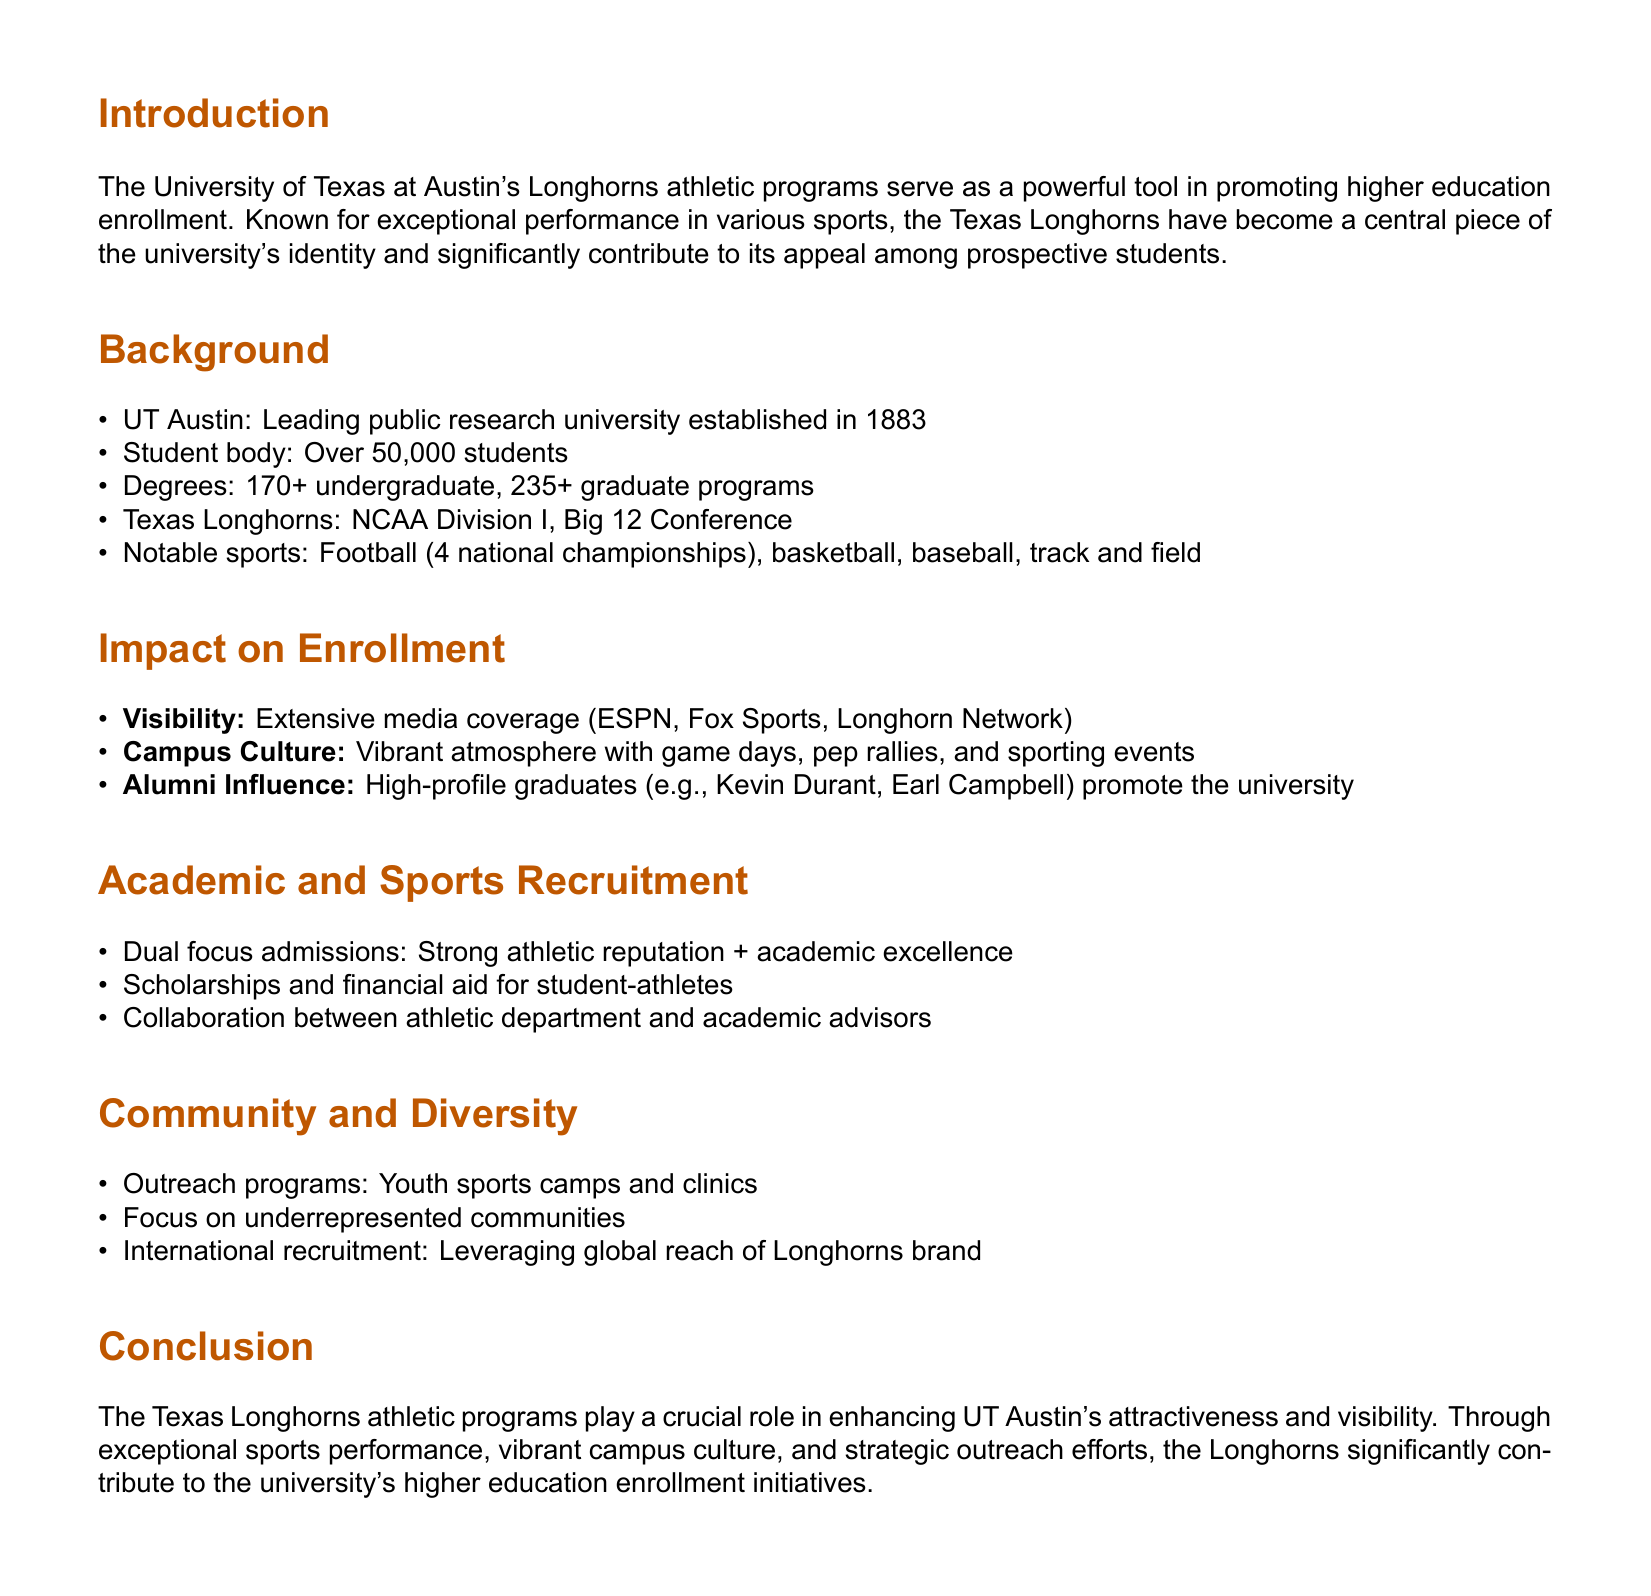What is the student body size of UT Austin? The document states that the student body consists of over 50,000 students.
Answer: Over 50,000 students How many national championships has the Texas Longhorns football team won? The document mentions that the football team has won 4 national championships.
Answer: 4 What is the focus of outreach programs mentioned in the document? The document indicates that outreach programs focus on underrepresented communities.
Answer: Underrepresented communities Which media outlets provide extensive coverage of the Longhorns? The document lists ESPN, Fox Sports, and Longhorn Network as the media outlets providing coverage.
Answer: ESPN, Fox Sports, Longhorn Network What is the dual focus in admissions for student-athletes? The document states that the dual focus in admissions is on strong athletic reputation and academic excellence.
Answer: Strong athletic reputation + academic excellence Who are two notable alumni mentioned that promote the university? The document cites Kevin Durant and Earl Campbell as high-profile graduates.
Answer: Kevin Durant, Earl Campbell What color represents the Texas Longhorns brand in this document? The document uses the RGB representation of burnt orange for the Texas Longhorns brand.
Answer: Burnt Orange What type of scholarships are provided for student-athletes? The document notes that scholarships and financial aid are available for student-athletes.
Answer: Scholarships and financial aid What year was UT Austin established? The document states that UT Austin was established in 1883.
Answer: 1883 What is the concluding statement about the Texas Longhorns athletic programs? The document concludes that the athletic programs significantly contribute to higher education enrollment initiatives.
Answer: Significantly contribute to higher education enrollment initiatives 